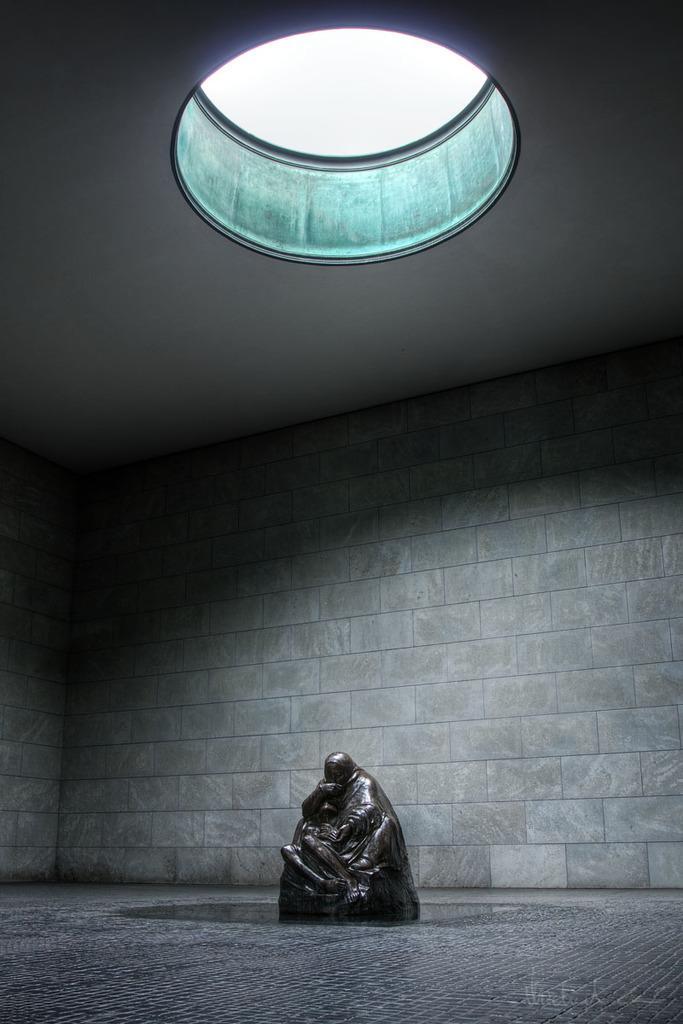In one or two sentences, can you explain what this image depicts? In this image I can see the statue. In the background I can see the wall. 